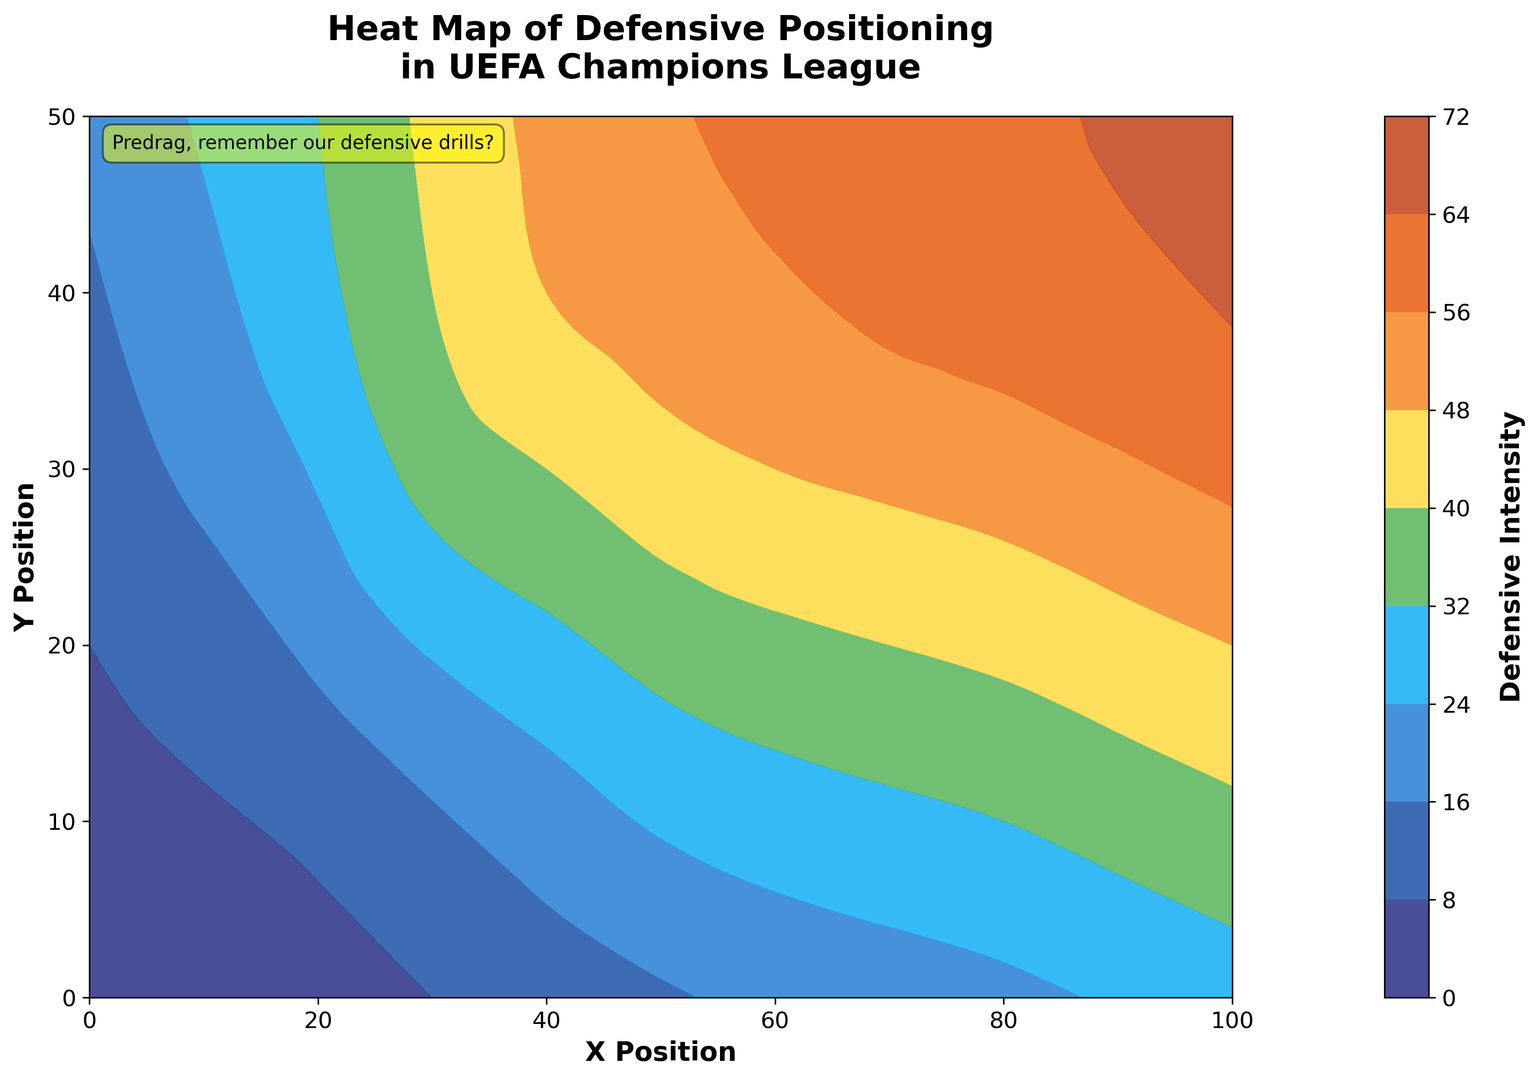What area on the pitch exhibits the highest defensive intensity? To determine the highest defensive intensity, look at which region has the darkest color on the map. The darkest color represents the highest defensive intensity. Thus, the top-left region in dark red signifies the highest intensity.
Answer: Top left How does the defensive intensity change from the bottom to the top? Observe the gradient of colors from the bottom to the top region. The colors transition from lighter to darker shades, indicating that defensive intensity increases as you move upward.
Answer: Increases Which position has a higher defensive intensity: (30, 10) or (60, 10)? Look at the colors at positions (30, 10) and (60, 10). Position (30, 10) is lighter in color than position (60, 10), indicating a lower intensity.
Answer: (60, 10) Is the defensive intensity more concentrated on the left or right side of the pitch? Compare the colors on the left and right halves of the pitch. The left half has predominantly darker colors, indicating higher defensive intensity compared to the right.
Answer: Left What is the median defensive intensity value for positions along the X-coordinate of 50? The Y-coordinates for X=50 have intensities of 15, 25, 35, 45, 52, and 55. To find the median, arrange these values: 15, 25, 35, 45, 52, 55. The median is the average of the two middle values: (35 + 45) / 2 = 40.
Answer: 40 Which color represents the defensive intensity around the center of the pitch (50, 25)? Find the color corresponding to position (50, 25) on the heat map. This position is represented by a middle shade on the color gradient, approximately green.
Answer: Green How does the intensity at (90, 30) compare to that at (40, 40)? Locate (90, 30) and (40, 40) on the map and compare their colors. Both positions have shades close to each other, but (40, 40) appears darker, indicating a slightly higher intensity.
Answer: (40, 40) What can you infer about the defensive strategy on the top half of the pitch based on color intensity? The top half of the pitch generally has darker shades, indicating higher defensive intensity. This suggests that successful teams concentrate their defense strategy more intensely in the top half.
Answer: More intense defense Which area shows a moderate defensive intensity between the coordinates (20, 20) and (70, 40)? Compare the colors between (20, 20) and (70, 40). Observe the intermediate shades appearing in the moderate intensity range, typically around (40, 30).
Answer: Around (40, 30) How does the defensive intensity vary spatially along the X=0 line? Observe the changes in color intensity along Y-values corresponding to X=0. The colors go from lighter to darker shades as Y increases, implying defensive intensity increases from bottom to top along this line.
Answer: Varies from low to high 